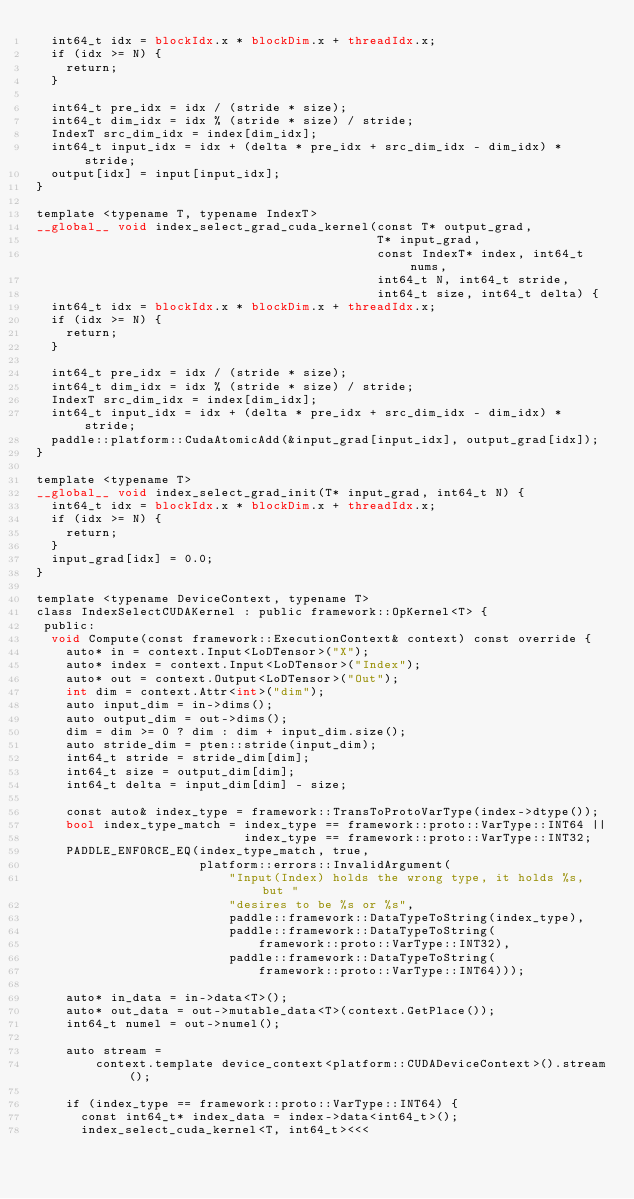Convert code to text. <code><loc_0><loc_0><loc_500><loc_500><_Cuda_>  int64_t idx = blockIdx.x * blockDim.x + threadIdx.x;
  if (idx >= N) {
    return;
  }

  int64_t pre_idx = idx / (stride * size);
  int64_t dim_idx = idx % (stride * size) / stride;
  IndexT src_dim_idx = index[dim_idx];
  int64_t input_idx = idx + (delta * pre_idx + src_dim_idx - dim_idx) * stride;
  output[idx] = input[input_idx];
}

template <typename T, typename IndexT>
__global__ void index_select_grad_cuda_kernel(const T* output_grad,
                                              T* input_grad,
                                              const IndexT* index, int64_t nums,
                                              int64_t N, int64_t stride,
                                              int64_t size, int64_t delta) {
  int64_t idx = blockIdx.x * blockDim.x + threadIdx.x;
  if (idx >= N) {
    return;
  }

  int64_t pre_idx = idx / (stride * size);
  int64_t dim_idx = idx % (stride * size) / stride;
  IndexT src_dim_idx = index[dim_idx];
  int64_t input_idx = idx + (delta * pre_idx + src_dim_idx - dim_idx) * stride;
  paddle::platform::CudaAtomicAdd(&input_grad[input_idx], output_grad[idx]);
}

template <typename T>
__global__ void index_select_grad_init(T* input_grad, int64_t N) {
  int64_t idx = blockIdx.x * blockDim.x + threadIdx.x;
  if (idx >= N) {
    return;
  }
  input_grad[idx] = 0.0;
}

template <typename DeviceContext, typename T>
class IndexSelectCUDAKernel : public framework::OpKernel<T> {
 public:
  void Compute(const framework::ExecutionContext& context) const override {
    auto* in = context.Input<LoDTensor>("X");
    auto* index = context.Input<LoDTensor>("Index");
    auto* out = context.Output<LoDTensor>("Out");
    int dim = context.Attr<int>("dim");
    auto input_dim = in->dims();
    auto output_dim = out->dims();
    dim = dim >= 0 ? dim : dim + input_dim.size();
    auto stride_dim = pten::stride(input_dim);
    int64_t stride = stride_dim[dim];
    int64_t size = output_dim[dim];
    int64_t delta = input_dim[dim] - size;

    const auto& index_type = framework::TransToProtoVarType(index->dtype());
    bool index_type_match = index_type == framework::proto::VarType::INT64 ||
                            index_type == framework::proto::VarType::INT32;
    PADDLE_ENFORCE_EQ(index_type_match, true,
                      platform::errors::InvalidArgument(
                          "Input(Index) holds the wrong type, it holds %s, but "
                          "desires to be %s or %s",
                          paddle::framework::DataTypeToString(index_type),
                          paddle::framework::DataTypeToString(
                              framework::proto::VarType::INT32),
                          paddle::framework::DataTypeToString(
                              framework::proto::VarType::INT64)));

    auto* in_data = in->data<T>();
    auto* out_data = out->mutable_data<T>(context.GetPlace());
    int64_t numel = out->numel();

    auto stream =
        context.template device_context<platform::CUDADeviceContext>().stream();

    if (index_type == framework::proto::VarType::INT64) {
      const int64_t* index_data = index->data<int64_t>();
      index_select_cuda_kernel<T, int64_t><<<</code> 